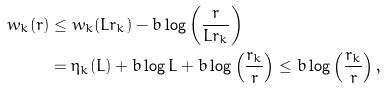Convert formula to latex. <formula><loc_0><loc_0><loc_500><loc_500>w _ { k } ( r ) & \leq w _ { k } ( L r _ { k } ) - b \log \left ( \frac { r } { L r _ { k } } \right ) \\ & = \eta _ { k } ( L ) + b \log L + b \log \left ( \frac { r _ { k } } { r } \right ) \leq b \log \left ( \frac { r _ { k } } { r } \right ) ,</formula> 